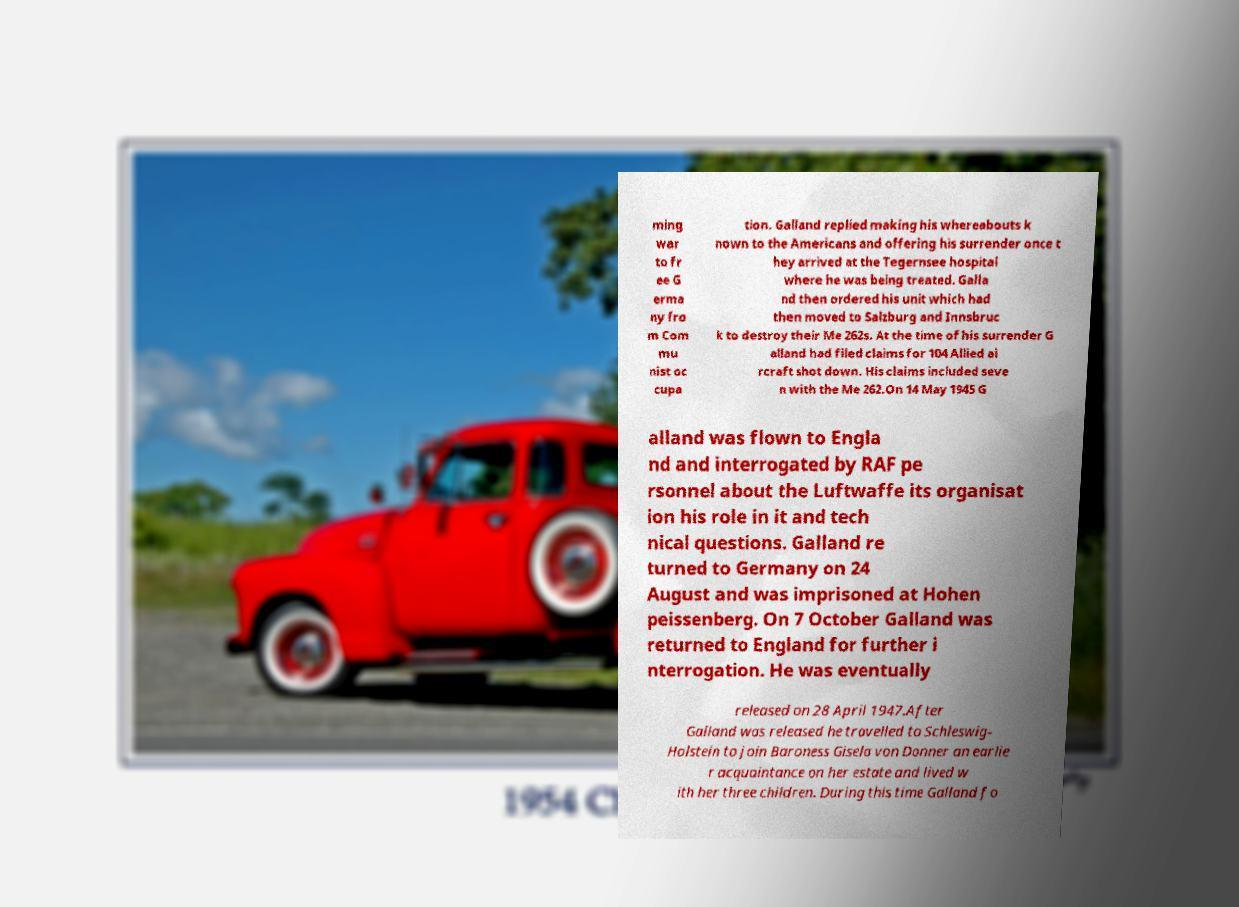For documentation purposes, I need the text within this image transcribed. Could you provide that? ming war to fr ee G erma ny fro m Com mu nist oc cupa tion. Galland replied making his whereabouts k nown to the Americans and offering his surrender once t hey arrived at the Tegernsee hospital where he was being treated. Galla nd then ordered his unit which had then moved to Salzburg and Innsbruc k to destroy their Me 262s. At the time of his surrender G alland had filed claims for 104 Allied ai rcraft shot down. His claims included seve n with the Me 262.On 14 May 1945 G alland was flown to Engla nd and interrogated by RAF pe rsonnel about the Luftwaffe its organisat ion his role in it and tech nical questions. Galland re turned to Germany on 24 August and was imprisoned at Hohen peissenberg. On 7 October Galland was returned to England for further i nterrogation. He was eventually released on 28 April 1947.After Galland was released he travelled to Schleswig- Holstein to join Baroness Gisela von Donner an earlie r acquaintance on her estate and lived w ith her three children. During this time Galland fo 